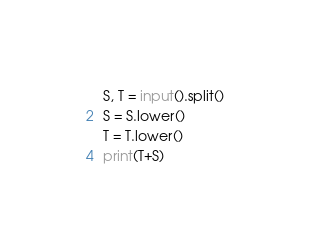Convert code to text. <code><loc_0><loc_0><loc_500><loc_500><_Python_>S, T = input().split()
S = S.lower()
T = T.lower()
print(T+S)</code> 